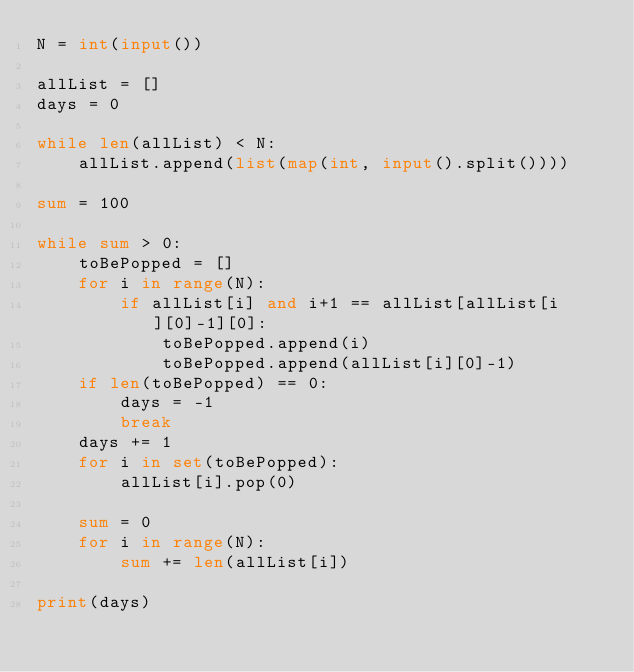<code> <loc_0><loc_0><loc_500><loc_500><_Python_>N = int(input())

allList = []
days = 0

while len(allList) < N:
    allList.append(list(map(int, input().split())))

sum = 100

while sum > 0:
    toBePopped = []
    for i in range(N):
        if allList[i] and i+1 == allList[allList[i][0]-1][0]:
            toBePopped.append(i)
            toBePopped.append(allList[i][0]-1)
    if len(toBePopped) == 0:
        days = -1
        break
    days += 1
    for i in set(toBePopped):
        allList[i].pop(0)

    sum = 0
    for i in range(N):
        sum += len(allList[i])

print(days)
</code> 